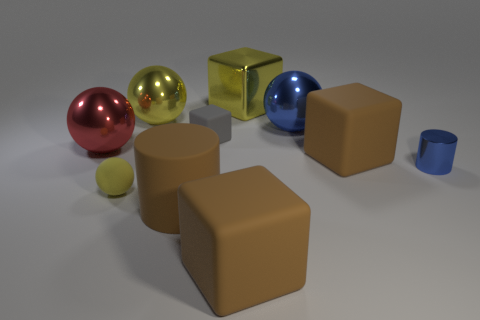Subtract all cubes. How many objects are left? 6 Subtract 0 green cylinders. How many objects are left? 10 Subtract all brown cylinders. Subtract all tiny cyan matte balls. How many objects are left? 9 Add 3 big blue metallic objects. How many big blue metallic objects are left? 4 Add 3 tiny metallic objects. How many tiny metallic objects exist? 4 